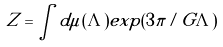Convert formula to latex. <formula><loc_0><loc_0><loc_500><loc_500>Z = \int d \mu ( \Lambda ) e x p ( 3 \pi / G \Lambda )</formula> 